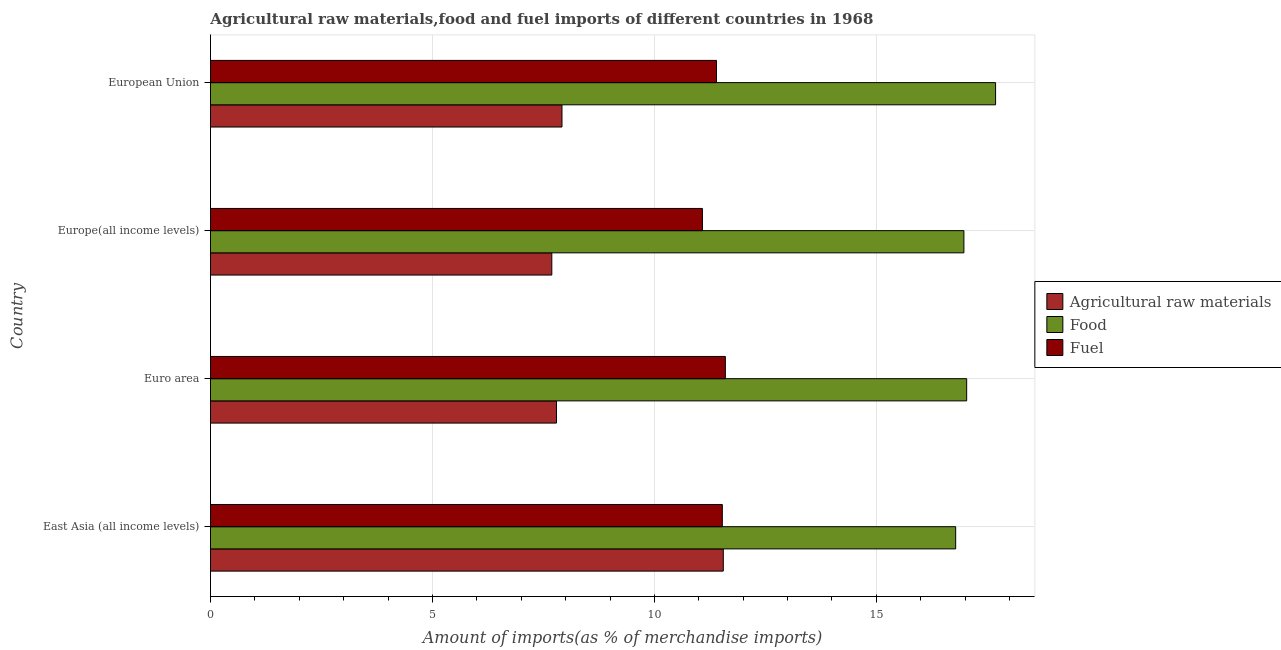How many different coloured bars are there?
Provide a short and direct response. 3. How many groups of bars are there?
Offer a terse response. 4. How many bars are there on the 1st tick from the bottom?
Keep it short and to the point. 3. What is the label of the 3rd group of bars from the top?
Your answer should be very brief. Euro area. In how many cases, is the number of bars for a given country not equal to the number of legend labels?
Your response must be concise. 0. What is the percentage of fuel imports in Europe(all income levels)?
Your answer should be very brief. 11.08. Across all countries, what is the maximum percentage of fuel imports?
Give a very brief answer. 11.6. Across all countries, what is the minimum percentage of fuel imports?
Give a very brief answer. 11.08. In which country was the percentage of raw materials imports maximum?
Offer a very short reply. East Asia (all income levels). In which country was the percentage of raw materials imports minimum?
Your answer should be very brief. Europe(all income levels). What is the total percentage of food imports in the graph?
Offer a terse response. 68.48. What is the difference between the percentage of fuel imports in East Asia (all income levels) and that in European Union?
Give a very brief answer. 0.13. What is the difference between the percentage of food imports in Europe(all income levels) and the percentage of fuel imports in European Union?
Keep it short and to the point. 5.57. What is the average percentage of food imports per country?
Ensure brevity in your answer.  17.12. What is the difference between the percentage of raw materials imports and percentage of food imports in Europe(all income levels)?
Ensure brevity in your answer.  -9.28. In how many countries, is the percentage of fuel imports greater than 9 %?
Offer a terse response. 4. What is the difference between the highest and the second highest percentage of fuel imports?
Keep it short and to the point. 0.07. What is the difference between the highest and the lowest percentage of raw materials imports?
Make the answer very short. 3.86. In how many countries, is the percentage of food imports greater than the average percentage of food imports taken over all countries?
Your answer should be compact. 1. Is the sum of the percentage of food imports in Euro area and European Union greater than the maximum percentage of raw materials imports across all countries?
Offer a terse response. Yes. What does the 3rd bar from the top in European Union represents?
Provide a succinct answer. Agricultural raw materials. What does the 2nd bar from the bottom in East Asia (all income levels) represents?
Give a very brief answer. Food. How many bars are there?
Offer a terse response. 12. Are all the bars in the graph horizontal?
Offer a terse response. Yes. How many countries are there in the graph?
Your answer should be compact. 4. What is the difference between two consecutive major ticks on the X-axis?
Provide a succinct answer. 5. Does the graph contain any zero values?
Offer a terse response. No. How many legend labels are there?
Make the answer very short. 3. What is the title of the graph?
Ensure brevity in your answer.  Agricultural raw materials,food and fuel imports of different countries in 1968. Does "Machinery" appear as one of the legend labels in the graph?
Keep it short and to the point. No. What is the label or title of the X-axis?
Your answer should be compact. Amount of imports(as % of merchandise imports). What is the label or title of the Y-axis?
Make the answer very short. Country. What is the Amount of imports(as % of merchandise imports) of Agricultural raw materials in East Asia (all income levels)?
Ensure brevity in your answer.  11.55. What is the Amount of imports(as % of merchandise imports) of Food in East Asia (all income levels)?
Give a very brief answer. 16.79. What is the Amount of imports(as % of merchandise imports) in Fuel in East Asia (all income levels)?
Your answer should be very brief. 11.53. What is the Amount of imports(as % of merchandise imports) of Agricultural raw materials in Euro area?
Your response must be concise. 7.79. What is the Amount of imports(as % of merchandise imports) of Food in Euro area?
Give a very brief answer. 17.03. What is the Amount of imports(as % of merchandise imports) in Fuel in Euro area?
Ensure brevity in your answer.  11.6. What is the Amount of imports(as % of merchandise imports) of Agricultural raw materials in Europe(all income levels)?
Offer a terse response. 7.69. What is the Amount of imports(as % of merchandise imports) of Food in Europe(all income levels)?
Provide a succinct answer. 16.97. What is the Amount of imports(as % of merchandise imports) in Fuel in Europe(all income levels)?
Make the answer very short. 11.08. What is the Amount of imports(as % of merchandise imports) in Agricultural raw materials in European Union?
Offer a very short reply. 7.92. What is the Amount of imports(as % of merchandise imports) of Food in European Union?
Make the answer very short. 17.69. What is the Amount of imports(as % of merchandise imports) in Fuel in European Union?
Your answer should be compact. 11.4. Across all countries, what is the maximum Amount of imports(as % of merchandise imports) of Agricultural raw materials?
Give a very brief answer. 11.55. Across all countries, what is the maximum Amount of imports(as % of merchandise imports) of Food?
Ensure brevity in your answer.  17.69. Across all countries, what is the maximum Amount of imports(as % of merchandise imports) of Fuel?
Offer a very short reply. 11.6. Across all countries, what is the minimum Amount of imports(as % of merchandise imports) of Agricultural raw materials?
Keep it short and to the point. 7.69. Across all countries, what is the minimum Amount of imports(as % of merchandise imports) in Food?
Provide a short and direct response. 16.79. Across all countries, what is the minimum Amount of imports(as % of merchandise imports) in Fuel?
Keep it short and to the point. 11.08. What is the total Amount of imports(as % of merchandise imports) in Agricultural raw materials in the graph?
Offer a very short reply. 34.95. What is the total Amount of imports(as % of merchandise imports) of Food in the graph?
Your answer should be very brief. 68.48. What is the total Amount of imports(as % of merchandise imports) in Fuel in the graph?
Your answer should be compact. 45.61. What is the difference between the Amount of imports(as % of merchandise imports) in Agricultural raw materials in East Asia (all income levels) and that in Euro area?
Your answer should be very brief. 3.76. What is the difference between the Amount of imports(as % of merchandise imports) in Food in East Asia (all income levels) and that in Euro area?
Provide a short and direct response. -0.25. What is the difference between the Amount of imports(as % of merchandise imports) of Fuel in East Asia (all income levels) and that in Euro area?
Keep it short and to the point. -0.07. What is the difference between the Amount of imports(as % of merchandise imports) of Agricultural raw materials in East Asia (all income levels) and that in Europe(all income levels)?
Your response must be concise. 3.86. What is the difference between the Amount of imports(as % of merchandise imports) in Food in East Asia (all income levels) and that in Europe(all income levels)?
Ensure brevity in your answer.  -0.19. What is the difference between the Amount of imports(as % of merchandise imports) of Fuel in East Asia (all income levels) and that in Europe(all income levels)?
Your response must be concise. 0.45. What is the difference between the Amount of imports(as % of merchandise imports) of Agricultural raw materials in East Asia (all income levels) and that in European Union?
Offer a very short reply. 3.63. What is the difference between the Amount of imports(as % of merchandise imports) in Food in East Asia (all income levels) and that in European Union?
Your answer should be compact. -0.9. What is the difference between the Amount of imports(as % of merchandise imports) in Fuel in East Asia (all income levels) and that in European Union?
Provide a short and direct response. 0.13. What is the difference between the Amount of imports(as % of merchandise imports) in Agricultural raw materials in Euro area and that in Europe(all income levels)?
Keep it short and to the point. 0.11. What is the difference between the Amount of imports(as % of merchandise imports) of Food in Euro area and that in Europe(all income levels)?
Your answer should be very brief. 0.06. What is the difference between the Amount of imports(as % of merchandise imports) of Fuel in Euro area and that in Europe(all income levels)?
Offer a terse response. 0.52. What is the difference between the Amount of imports(as % of merchandise imports) of Agricultural raw materials in Euro area and that in European Union?
Provide a succinct answer. -0.12. What is the difference between the Amount of imports(as % of merchandise imports) of Food in Euro area and that in European Union?
Ensure brevity in your answer.  -0.65. What is the difference between the Amount of imports(as % of merchandise imports) in Fuel in Euro area and that in European Union?
Ensure brevity in your answer.  0.2. What is the difference between the Amount of imports(as % of merchandise imports) in Agricultural raw materials in Europe(all income levels) and that in European Union?
Keep it short and to the point. -0.23. What is the difference between the Amount of imports(as % of merchandise imports) in Food in Europe(all income levels) and that in European Union?
Offer a very short reply. -0.71. What is the difference between the Amount of imports(as % of merchandise imports) in Fuel in Europe(all income levels) and that in European Union?
Keep it short and to the point. -0.32. What is the difference between the Amount of imports(as % of merchandise imports) in Agricultural raw materials in East Asia (all income levels) and the Amount of imports(as % of merchandise imports) in Food in Euro area?
Keep it short and to the point. -5.48. What is the difference between the Amount of imports(as % of merchandise imports) in Agricultural raw materials in East Asia (all income levels) and the Amount of imports(as % of merchandise imports) in Fuel in Euro area?
Your response must be concise. -0.05. What is the difference between the Amount of imports(as % of merchandise imports) of Food in East Asia (all income levels) and the Amount of imports(as % of merchandise imports) of Fuel in Euro area?
Offer a very short reply. 5.19. What is the difference between the Amount of imports(as % of merchandise imports) in Agricultural raw materials in East Asia (all income levels) and the Amount of imports(as % of merchandise imports) in Food in Europe(all income levels)?
Give a very brief answer. -5.42. What is the difference between the Amount of imports(as % of merchandise imports) in Agricultural raw materials in East Asia (all income levels) and the Amount of imports(as % of merchandise imports) in Fuel in Europe(all income levels)?
Provide a short and direct response. 0.47. What is the difference between the Amount of imports(as % of merchandise imports) of Food in East Asia (all income levels) and the Amount of imports(as % of merchandise imports) of Fuel in Europe(all income levels)?
Offer a very short reply. 5.7. What is the difference between the Amount of imports(as % of merchandise imports) in Agricultural raw materials in East Asia (all income levels) and the Amount of imports(as % of merchandise imports) in Food in European Union?
Your answer should be very brief. -6.13. What is the difference between the Amount of imports(as % of merchandise imports) of Agricultural raw materials in East Asia (all income levels) and the Amount of imports(as % of merchandise imports) of Fuel in European Union?
Offer a terse response. 0.15. What is the difference between the Amount of imports(as % of merchandise imports) in Food in East Asia (all income levels) and the Amount of imports(as % of merchandise imports) in Fuel in European Union?
Keep it short and to the point. 5.39. What is the difference between the Amount of imports(as % of merchandise imports) of Agricultural raw materials in Euro area and the Amount of imports(as % of merchandise imports) of Food in Europe(all income levels)?
Offer a very short reply. -9.18. What is the difference between the Amount of imports(as % of merchandise imports) of Agricultural raw materials in Euro area and the Amount of imports(as % of merchandise imports) of Fuel in Europe(all income levels)?
Your answer should be compact. -3.29. What is the difference between the Amount of imports(as % of merchandise imports) in Food in Euro area and the Amount of imports(as % of merchandise imports) in Fuel in Europe(all income levels)?
Provide a short and direct response. 5.95. What is the difference between the Amount of imports(as % of merchandise imports) of Agricultural raw materials in Euro area and the Amount of imports(as % of merchandise imports) of Food in European Union?
Your answer should be compact. -9.89. What is the difference between the Amount of imports(as % of merchandise imports) of Agricultural raw materials in Euro area and the Amount of imports(as % of merchandise imports) of Fuel in European Union?
Your response must be concise. -3.6. What is the difference between the Amount of imports(as % of merchandise imports) of Food in Euro area and the Amount of imports(as % of merchandise imports) of Fuel in European Union?
Offer a terse response. 5.64. What is the difference between the Amount of imports(as % of merchandise imports) in Agricultural raw materials in Europe(all income levels) and the Amount of imports(as % of merchandise imports) in Food in European Union?
Your response must be concise. -10. What is the difference between the Amount of imports(as % of merchandise imports) of Agricultural raw materials in Europe(all income levels) and the Amount of imports(as % of merchandise imports) of Fuel in European Union?
Keep it short and to the point. -3.71. What is the difference between the Amount of imports(as % of merchandise imports) in Food in Europe(all income levels) and the Amount of imports(as % of merchandise imports) in Fuel in European Union?
Ensure brevity in your answer.  5.57. What is the average Amount of imports(as % of merchandise imports) of Agricultural raw materials per country?
Provide a succinct answer. 8.74. What is the average Amount of imports(as % of merchandise imports) of Food per country?
Offer a very short reply. 17.12. What is the average Amount of imports(as % of merchandise imports) in Fuel per country?
Ensure brevity in your answer.  11.4. What is the difference between the Amount of imports(as % of merchandise imports) in Agricultural raw materials and Amount of imports(as % of merchandise imports) in Food in East Asia (all income levels)?
Provide a short and direct response. -5.23. What is the difference between the Amount of imports(as % of merchandise imports) in Agricultural raw materials and Amount of imports(as % of merchandise imports) in Fuel in East Asia (all income levels)?
Offer a terse response. 0.02. What is the difference between the Amount of imports(as % of merchandise imports) in Food and Amount of imports(as % of merchandise imports) in Fuel in East Asia (all income levels)?
Keep it short and to the point. 5.26. What is the difference between the Amount of imports(as % of merchandise imports) in Agricultural raw materials and Amount of imports(as % of merchandise imports) in Food in Euro area?
Your answer should be compact. -9.24. What is the difference between the Amount of imports(as % of merchandise imports) in Agricultural raw materials and Amount of imports(as % of merchandise imports) in Fuel in Euro area?
Offer a very short reply. -3.8. What is the difference between the Amount of imports(as % of merchandise imports) in Food and Amount of imports(as % of merchandise imports) in Fuel in Euro area?
Give a very brief answer. 5.44. What is the difference between the Amount of imports(as % of merchandise imports) of Agricultural raw materials and Amount of imports(as % of merchandise imports) of Food in Europe(all income levels)?
Your response must be concise. -9.28. What is the difference between the Amount of imports(as % of merchandise imports) in Agricultural raw materials and Amount of imports(as % of merchandise imports) in Fuel in Europe(all income levels)?
Your answer should be very brief. -3.39. What is the difference between the Amount of imports(as % of merchandise imports) in Food and Amount of imports(as % of merchandise imports) in Fuel in Europe(all income levels)?
Provide a short and direct response. 5.89. What is the difference between the Amount of imports(as % of merchandise imports) of Agricultural raw materials and Amount of imports(as % of merchandise imports) of Food in European Union?
Your answer should be very brief. -9.77. What is the difference between the Amount of imports(as % of merchandise imports) in Agricultural raw materials and Amount of imports(as % of merchandise imports) in Fuel in European Union?
Your answer should be compact. -3.48. What is the difference between the Amount of imports(as % of merchandise imports) of Food and Amount of imports(as % of merchandise imports) of Fuel in European Union?
Ensure brevity in your answer.  6.29. What is the ratio of the Amount of imports(as % of merchandise imports) in Agricultural raw materials in East Asia (all income levels) to that in Euro area?
Offer a very short reply. 1.48. What is the ratio of the Amount of imports(as % of merchandise imports) in Food in East Asia (all income levels) to that in Euro area?
Your answer should be compact. 0.99. What is the ratio of the Amount of imports(as % of merchandise imports) of Agricultural raw materials in East Asia (all income levels) to that in Europe(all income levels)?
Offer a very short reply. 1.5. What is the ratio of the Amount of imports(as % of merchandise imports) of Food in East Asia (all income levels) to that in Europe(all income levels)?
Offer a terse response. 0.99. What is the ratio of the Amount of imports(as % of merchandise imports) of Fuel in East Asia (all income levels) to that in Europe(all income levels)?
Your answer should be compact. 1.04. What is the ratio of the Amount of imports(as % of merchandise imports) in Agricultural raw materials in East Asia (all income levels) to that in European Union?
Make the answer very short. 1.46. What is the ratio of the Amount of imports(as % of merchandise imports) in Food in East Asia (all income levels) to that in European Union?
Ensure brevity in your answer.  0.95. What is the ratio of the Amount of imports(as % of merchandise imports) in Fuel in East Asia (all income levels) to that in European Union?
Your answer should be compact. 1.01. What is the ratio of the Amount of imports(as % of merchandise imports) of Agricultural raw materials in Euro area to that in Europe(all income levels)?
Give a very brief answer. 1.01. What is the ratio of the Amount of imports(as % of merchandise imports) of Fuel in Euro area to that in Europe(all income levels)?
Your answer should be very brief. 1.05. What is the ratio of the Amount of imports(as % of merchandise imports) of Agricultural raw materials in Euro area to that in European Union?
Keep it short and to the point. 0.98. What is the ratio of the Amount of imports(as % of merchandise imports) of Food in Euro area to that in European Union?
Offer a very short reply. 0.96. What is the ratio of the Amount of imports(as % of merchandise imports) of Fuel in Euro area to that in European Union?
Your answer should be compact. 1.02. What is the ratio of the Amount of imports(as % of merchandise imports) in Agricultural raw materials in Europe(all income levels) to that in European Union?
Keep it short and to the point. 0.97. What is the ratio of the Amount of imports(as % of merchandise imports) in Food in Europe(all income levels) to that in European Union?
Give a very brief answer. 0.96. What is the ratio of the Amount of imports(as % of merchandise imports) in Fuel in Europe(all income levels) to that in European Union?
Your response must be concise. 0.97. What is the difference between the highest and the second highest Amount of imports(as % of merchandise imports) of Agricultural raw materials?
Keep it short and to the point. 3.63. What is the difference between the highest and the second highest Amount of imports(as % of merchandise imports) of Food?
Make the answer very short. 0.65. What is the difference between the highest and the second highest Amount of imports(as % of merchandise imports) of Fuel?
Provide a succinct answer. 0.07. What is the difference between the highest and the lowest Amount of imports(as % of merchandise imports) of Agricultural raw materials?
Offer a very short reply. 3.86. What is the difference between the highest and the lowest Amount of imports(as % of merchandise imports) of Food?
Provide a short and direct response. 0.9. What is the difference between the highest and the lowest Amount of imports(as % of merchandise imports) of Fuel?
Give a very brief answer. 0.52. 